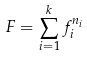Convert formula to latex. <formula><loc_0><loc_0><loc_500><loc_500>F = \sum _ { i = 1 } ^ { k } f _ { i } ^ { n _ { i } }</formula> 